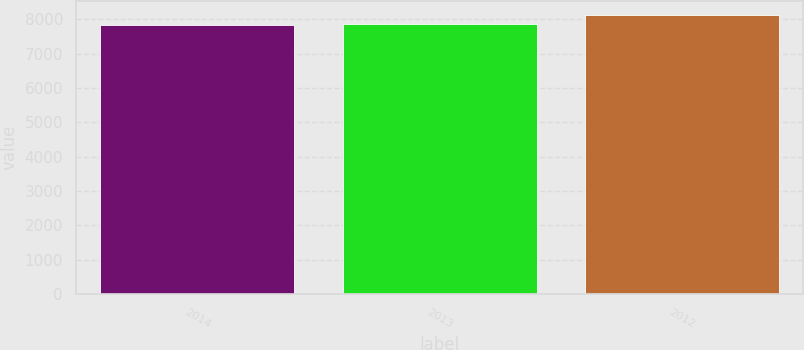Convert chart to OTSL. <chart><loc_0><loc_0><loc_500><loc_500><bar_chart><fcel>2014<fcel>2013<fcel>2012<nl><fcel>7844<fcel>7871.3<fcel>8117<nl></chart> 